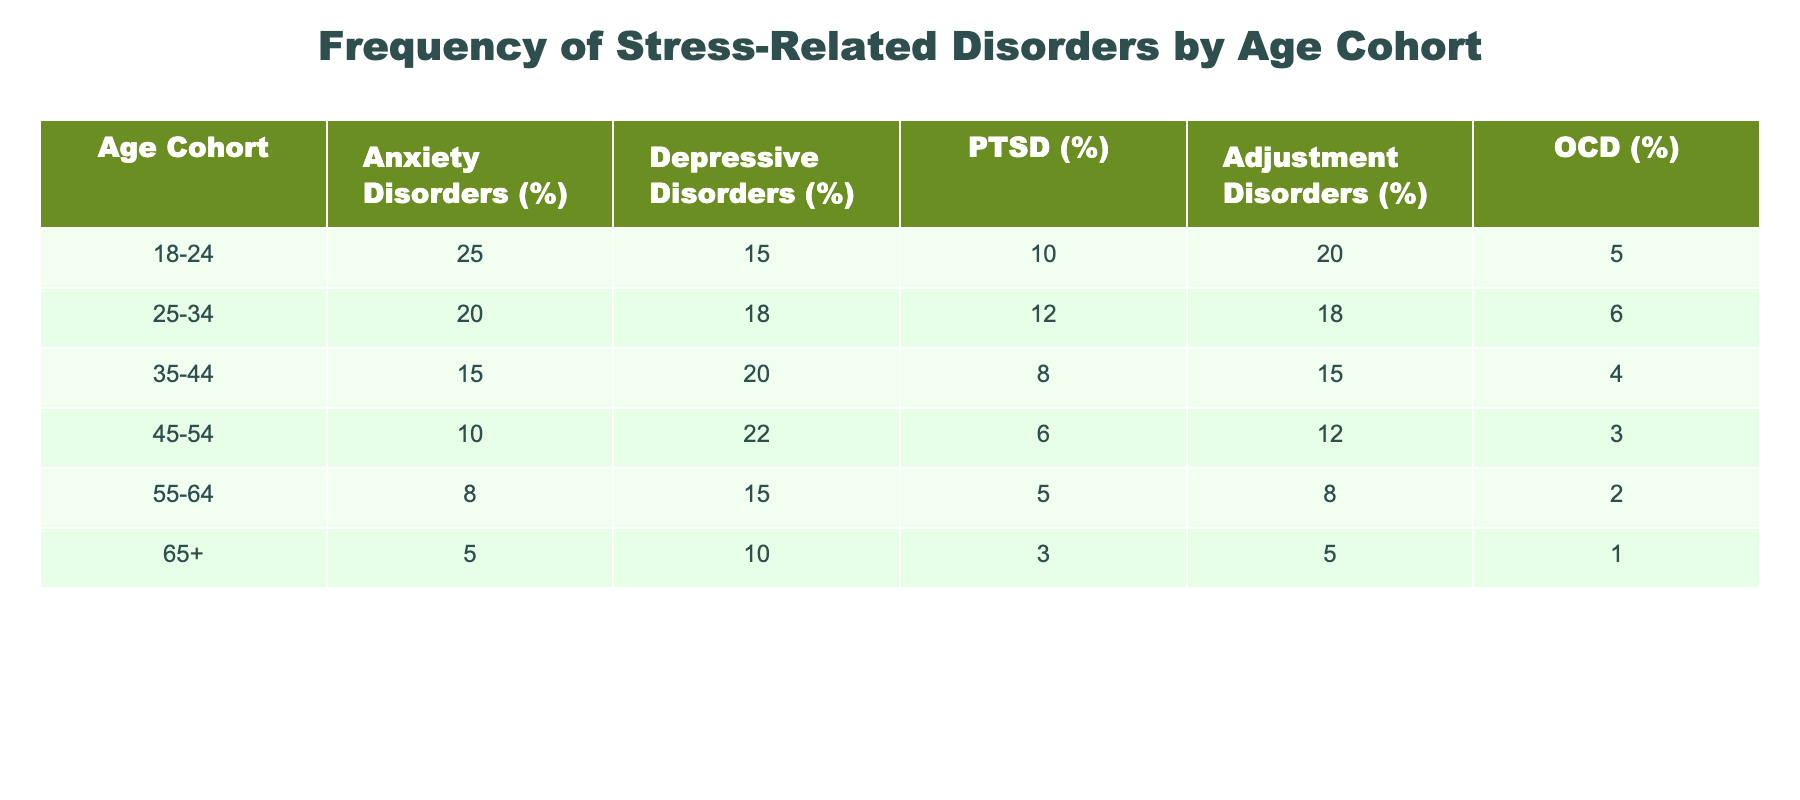What is the percentage of individuals aged 18-24 diagnosed with Anxiety Disorders? Referring to the row for the age cohort 18-24 in the table, the percentage listed under Anxiety Disorders is 25%.
Answer: 25% Which age cohort has the highest prevalence of Depressive Disorders? By examining the percentages listed under Depressive Disorders across all age cohorts, the cohort 45-54 has the highest percentage at 22%.
Answer: 45-54 What percentage of individuals aged 35-44 experience PTSD? The table indicates that the percentage of individuals in the age cohort 35-44 with PTSD is 8%.
Answer: 8% What is the average percentage of Adjustment Disorders across all age cohorts? Summing the percentages for Adjustment Disorders: 20 + 18 + 15 + 12 + 8 + 5 = 78. There are 6 age cohorts, so the average is 78 / 6 = 13.
Answer: 13% Is it true that individuals aged 65 and older have a higher percentage of OCD than those aged 55-64? The table shows that the percentage of OCD in the 65+ cohort is 1%, while the 55-64 cohort has 2%. Therefore, it is false.
Answer: No In which age cohort is the difference between Anxiety Disorders and Depressive Disorders the smallest? To find this, we calculate the differences: 18-24 (10%), 25-34 (2%), 35-44 (-5%), 45-54 (-12%), 55-64 (6%), 65+ (-5%). The smallest difference is in the 35-44 cohort, where Anxiety is lower than Depressive Disorders by 5%.
Answer: 35-44 How does the rate of PTSD for the 18-24 cohort compare to that of the 55-64 cohort? The percentage for the 18-24 cohort is 10%, while for the 55-64 cohort it is 5%. Comparing these values, the younger cohort has a higher rate by 5%.
Answer: Higher by 5% Which age cohort has lower rates of both Depression and OCD compared to the cohort immediately younger than it? By comparing the percentages: 45-54 (22% Depression, 3% OCD) to 35-44 (20% Depression, 4% OCD) shows 45-54 has higher Depression and lower OCD, while looking from 55-64 to 45-54, 55-64 is indeed lower for both (15% Depression, 2% OCD).
Answer: 55-64 What is the total percentage of Anxiety and Adjustment Disorders for the 25-34 cohort? The percentages for the 25-34 cohort are 20% for Anxiety Disorders and 18% for Adjustment Disorders. Adding them gives: 20 + 18 = 38%.
Answer: 38% 